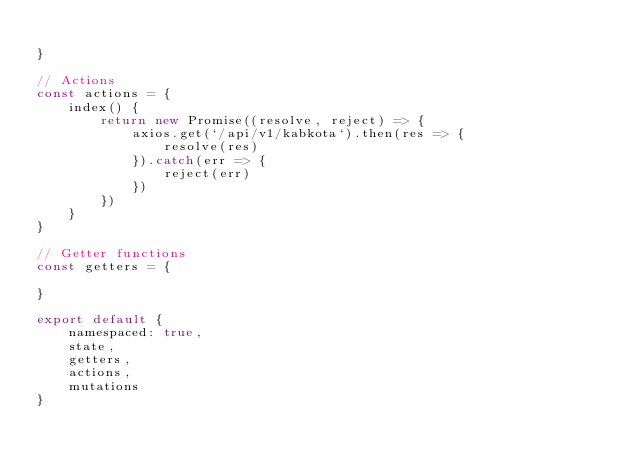<code> <loc_0><loc_0><loc_500><loc_500><_JavaScript_>
}

// Actions
const actions = {
    index() {
        return new Promise((resolve, reject) => {
            axios.get(`/api/v1/kabkota`).then(res => {
                resolve(res)
            }).catch(err => {
                reject(err)
            })
        })
    }
}

// Getter functions
const getters = {

}

export default {
    namespaced: true,
    state,
    getters,
    actions,
    mutations
}</code> 